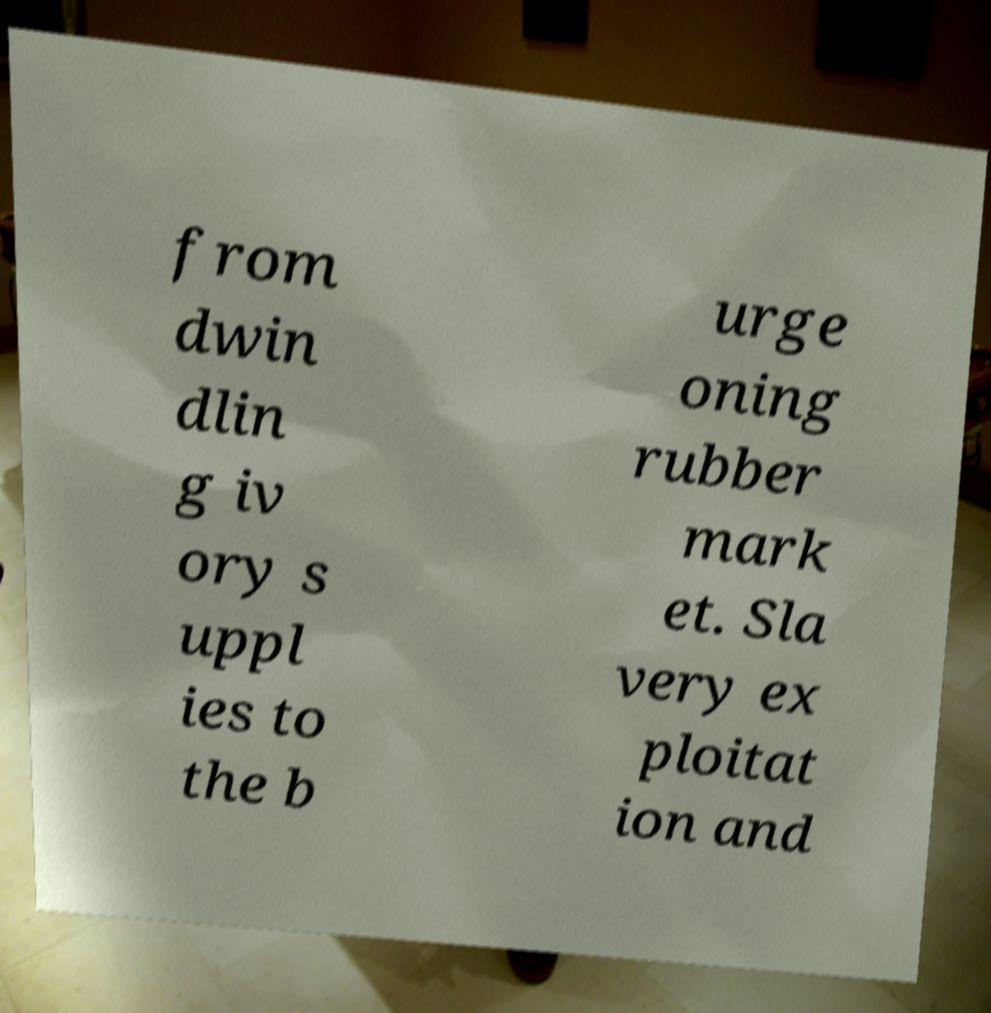I need the written content from this picture converted into text. Can you do that? from dwin dlin g iv ory s uppl ies to the b urge oning rubber mark et. Sla very ex ploitat ion and 